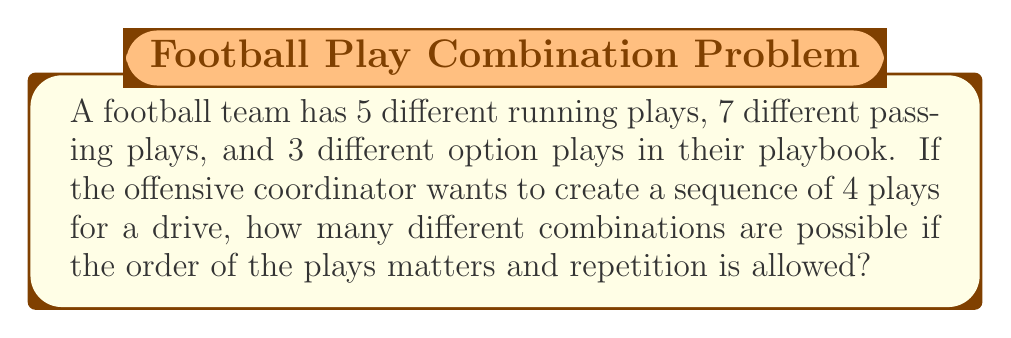Show me your answer to this math problem. Let's approach this step-by-step:

1) First, we need to determine the total number of plays available:
   $5 + 7 + 3 = 15$ total plays

2) Now, we're selecting 4 plays from these 15, where:
   - The order matters (a sequence)
   - Repetition is allowed (can use the same play multiple times)

3) This scenario calls for the use of permutations with repetition.

4) The formula for permutations with repetition is:
   $n^r$
   Where $n$ is the number of things to choose from, and $r$ is the number of times a choice is made.

5) In this case:
   $n = 15$ (total number of plays)
   $r = 4$ (number of plays in the sequence)

6) Applying the formula:
   $15^4 = 15 \times 15 \times 15 \times 15 = 50,625$

Therefore, there are 50,625 possible 4-play sequences that the offensive coordinator can create.
Answer: 50,625 